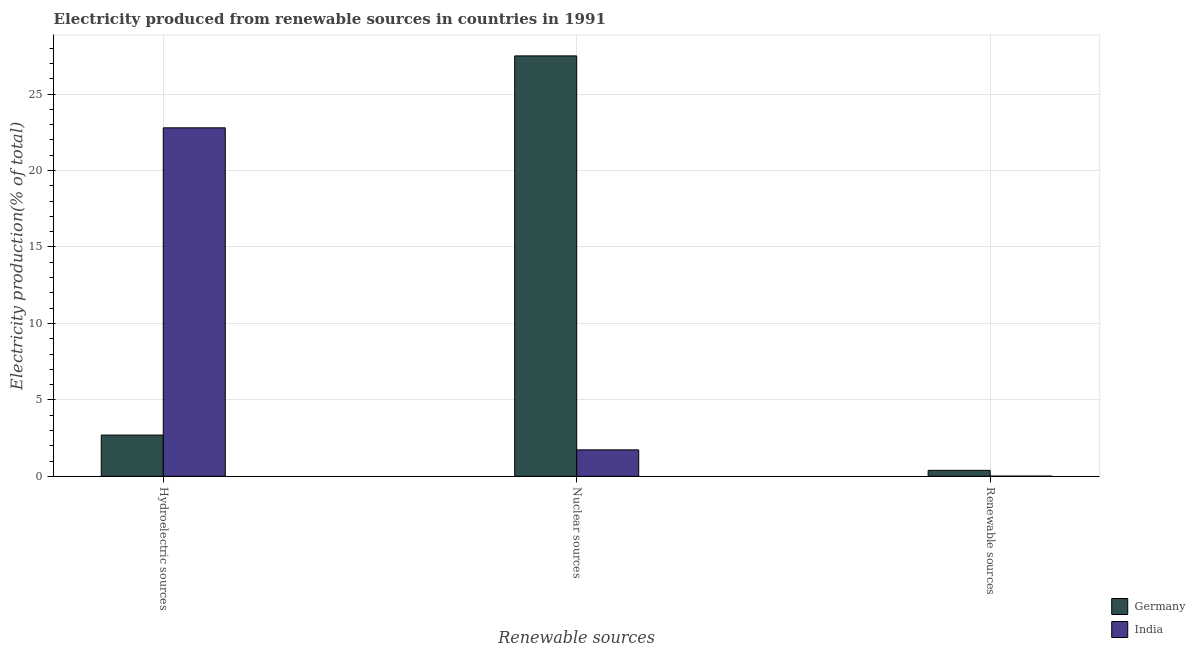How many different coloured bars are there?
Give a very brief answer. 2. Are the number of bars on each tick of the X-axis equal?
Keep it short and to the point. Yes. How many bars are there on the 1st tick from the left?
Provide a succinct answer. 2. How many bars are there on the 1st tick from the right?
Provide a short and direct response. 2. What is the label of the 1st group of bars from the left?
Make the answer very short. Hydroelectric sources. What is the percentage of electricity produced by hydroelectric sources in Germany?
Give a very brief answer. 2.7. Across all countries, what is the maximum percentage of electricity produced by hydroelectric sources?
Give a very brief answer. 22.8. Across all countries, what is the minimum percentage of electricity produced by nuclear sources?
Provide a succinct answer. 1.73. In which country was the percentage of electricity produced by renewable sources maximum?
Provide a succinct answer. Germany. What is the total percentage of electricity produced by nuclear sources in the graph?
Your answer should be compact. 29.23. What is the difference between the percentage of electricity produced by renewable sources in Germany and that in India?
Make the answer very short. 0.38. What is the difference between the percentage of electricity produced by hydroelectric sources in India and the percentage of electricity produced by renewable sources in Germany?
Your answer should be compact. 22.41. What is the average percentage of electricity produced by nuclear sources per country?
Offer a terse response. 14.62. What is the difference between the percentage of electricity produced by hydroelectric sources and percentage of electricity produced by nuclear sources in India?
Your answer should be compact. 21.06. What is the ratio of the percentage of electricity produced by nuclear sources in Germany to that in India?
Ensure brevity in your answer.  15.89. Is the percentage of electricity produced by nuclear sources in India less than that in Germany?
Your answer should be very brief. Yes. What is the difference between the highest and the second highest percentage of electricity produced by nuclear sources?
Give a very brief answer. 25.77. What is the difference between the highest and the lowest percentage of electricity produced by hydroelectric sources?
Give a very brief answer. 20.1. What does the 1st bar from the left in Hydroelectric sources represents?
Offer a very short reply. Germany. Is it the case that in every country, the sum of the percentage of electricity produced by hydroelectric sources and percentage of electricity produced by nuclear sources is greater than the percentage of electricity produced by renewable sources?
Give a very brief answer. Yes. Are all the bars in the graph horizontal?
Provide a succinct answer. No. How many countries are there in the graph?
Offer a very short reply. 2. Are the values on the major ticks of Y-axis written in scientific E-notation?
Ensure brevity in your answer.  No. Does the graph contain grids?
Make the answer very short. Yes. How many legend labels are there?
Give a very brief answer. 2. What is the title of the graph?
Your answer should be compact. Electricity produced from renewable sources in countries in 1991. What is the label or title of the X-axis?
Your response must be concise. Renewable sources. What is the label or title of the Y-axis?
Give a very brief answer. Electricity production(% of total). What is the Electricity production(% of total) of Germany in Hydroelectric sources?
Offer a terse response. 2.7. What is the Electricity production(% of total) in India in Hydroelectric sources?
Make the answer very short. 22.8. What is the Electricity production(% of total) of Germany in Nuclear sources?
Ensure brevity in your answer.  27.5. What is the Electricity production(% of total) in India in Nuclear sources?
Your answer should be very brief. 1.73. What is the Electricity production(% of total) of Germany in Renewable sources?
Your response must be concise. 0.39. What is the Electricity production(% of total) in India in Renewable sources?
Provide a short and direct response. 0.01. Across all Renewable sources, what is the maximum Electricity production(% of total) of Germany?
Offer a terse response. 27.5. Across all Renewable sources, what is the maximum Electricity production(% of total) in India?
Your answer should be compact. 22.8. Across all Renewable sources, what is the minimum Electricity production(% of total) in Germany?
Your answer should be very brief. 0.39. Across all Renewable sources, what is the minimum Electricity production(% of total) in India?
Give a very brief answer. 0.01. What is the total Electricity production(% of total) in Germany in the graph?
Your response must be concise. 30.59. What is the total Electricity production(% of total) in India in the graph?
Your response must be concise. 24.54. What is the difference between the Electricity production(% of total) in Germany in Hydroelectric sources and that in Nuclear sources?
Make the answer very short. -24.8. What is the difference between the Electricity production(% of total) in India in Hydroelectric sources and that in Nuclear sources?
Provide a short and direct response. 21.06. What is the difference between the Electricity production(% of total) in Germany in Hydroelectric sources and that in Renewable sources?
Give a very brief answer. 2.31. What is the difference between the Electricity production(% of total) of India in Hydroelectric sources and that in Renewable sources?
Ensure brevity in your answer.  22.78. What is the difference between the Electricity production(% of total) of Germany in Nuclear sources and that in Renewable sources?
Provide a short and direct response. 27.11. What is the difference between the Electricity production(% of total) of India in Nuclear sources and that in Renewable sources?
Offer a terse response. 1.72. What is the difference between the Electricity production(% of total) of Germany in Hydroelectric sources and the Electricity production(% of total) of India in Nuclear sources?
Offer a terse response. 0.97. What is the difference between the Electricity production(% of total) of Germany in Hydroelectric sources and the Electricity production(% of total) of India in Renewable sources?
Make the answer very short. 2.69. What is the difference between the Electricity production(% of total) in Germany in Nuclear sources and the Electricity production(% of total) in India in Renewable sources?
Ensure brevity in your answer.  27.49. What is the average Electricity production(% of total) of Germany per Renewable sources?
Ensure brevity in your answer.  10.2. What is the average Electricity production(% of total) in India per Renewable sources?
Ensure brevity in your answer.  8.18. What is the difference between the Electricity production(% of total) of Germany and Electricity production(% of total) of India in Hydroelectric sources?
Offer a terse response. -20.1. What is the difference between the Electricity production(% of total) in Germany and Electricity production(% of total) in India in Nuclear sources?
Your response must be concise. 25.77. What is the difference between the Electricity production(% of total) in Germany and Electricity production(% of total) in India in Renewable sources?
Offer a very short reply. 0.38. What is the ratio of the Electricity production(% of total) in Germany in Hydroelectric sources to that in Nuclear sources?
Provide a succinct answer. 0.1. What is the ratio of the Electricity production(% of total) in India in Hydroelectric sources to that in Nuclear sources?
Give a very brief answer. 13.17. What is the ratio of the Electricity production(% of total) of Germany in Hydroelectric sources to that in Renewable sources?
Your response must be concise. 6.92. What is the ratio of the Electricity production(% of total) in India in Hydroelectric sources to that in Renewable sources?
Make the answer very short. 1866.03. What is the ratio of the Electricity production(% of total) in Germany in Nuclear sources to that in Renewable sources?
Provide a short and direct response. 70.51. What is the ratio of the Electricity production(% of total) of India in Nuclear sources to that in Renewable sources?
Offer a terse response. 141.67. What is the difference between the highest and the second highest Electricity production(% of total) in Germany?
Provide a short and direct response. 24.8. What is the difference between the highest and the second highest Electricity production(% of total) of India?
Offer a terse response. 21.06. What is the difference between the highest and the lowest Electricity production(% of total) of Germany?
Offer a very short reply. 27.11. What is the difference between the highest and the lowest Electricity production(% of total) in India?
Your answer should be compact. 22.78. 